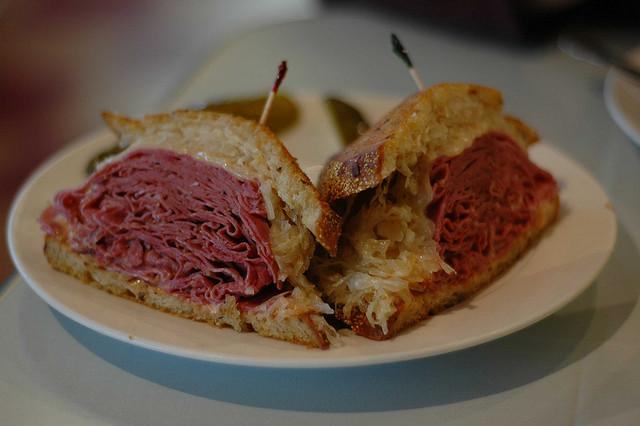What's the purpose of the little sticks?

Choices:
A) decoration
B) keep together
C) add flavor
D) test doneness keep together 